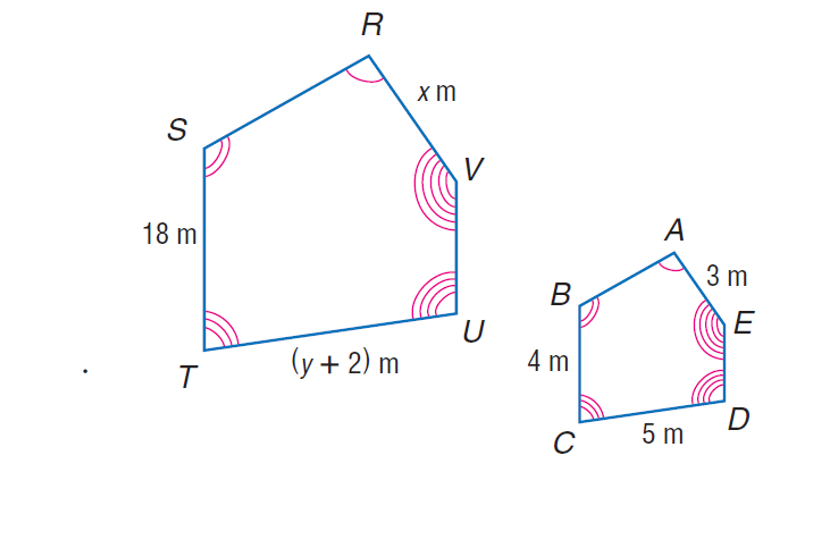Answer the mathemtical geometry problem and directly provide the correct option letter.
Question: The two polygons are similar. Find x.
Choices: A: 13.5 B: 18 C: 45 D: 200 A 